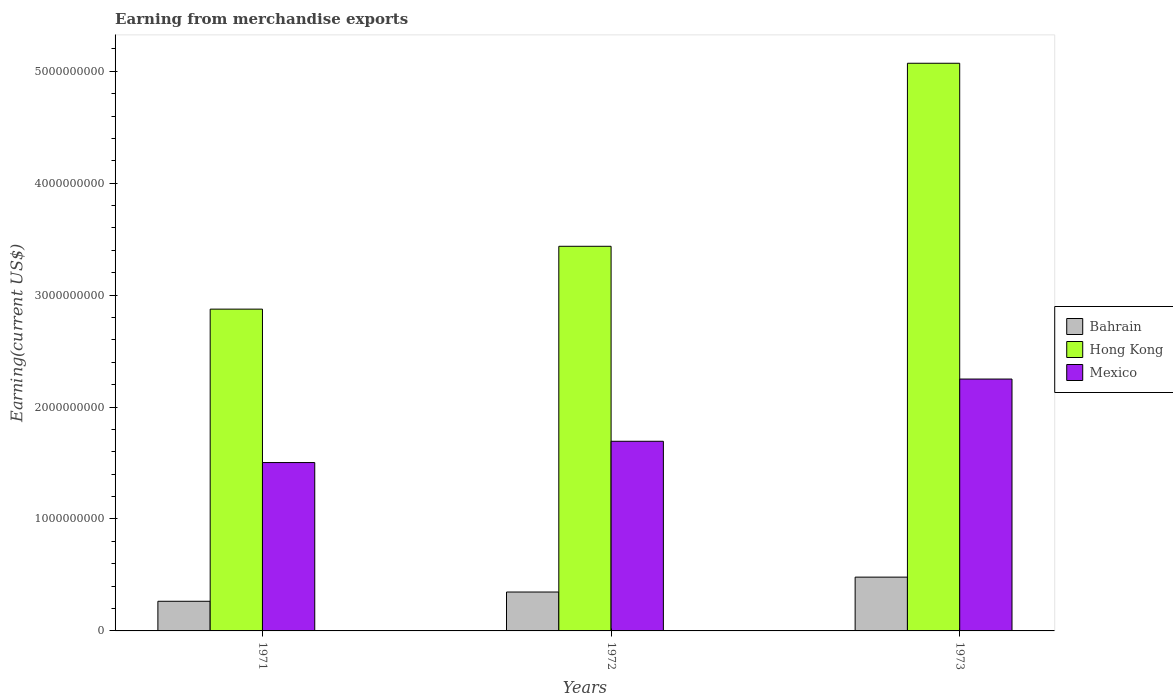How many different coloured bars are there?
Offer a terse response. 3. Are the number of bars per tick equal to the number of legend labels?
Offer a very short reply. Yes. Are the number of bars on each tick of the X-axis equal?
Offer a very short reply. Yes. In how many cases, is the number of bars for a given year not equal to the number of legend labels?
Your answer should be very brief. 0. What is the amount earned from merchandise exports in Bahrain in 1971?
Provide a succinct answer. 2.65e+08. Across all years, what is the maximum amount earned from merchandise exports in Hong Kong?
Your response must be concise. 5.07e+09. Across all years, what is the minimum amount earned from merchandise exports in Hong Kong?
Provide a succinct answer. 2.87e+09. In which year was the amount earned from merchandise exports in Bahrain minimum?
Make the answer very short. 1971. What is the total amount earned from merchandise exports in Mexico in the graph?
Offer a terse response. 5.45e+09. What is the difference between the amount earned from merchandise exports in Hong Kong in 1971 and that in 1973?
Keep it short and to the point. -2.20e+09. What is the difference between the amount earned from merchandise exports in Hong Kong in 1973 and the amount earned from merchandise exports in Mexico in 1972?
Make the answer very short. 3.38e+09. What is the average amount earned from merchandise exports in Bahrain per year?
Offer a very short reply. 3.64e+08. In the year 1972, what is the difference between the amount earned from merchandise exports in Mexico and amount earned from merchandise exports in Bahrain?
Ensure brevity in your answer.  1.35e+09. In how many years, is the amount earned from merchandise exports in Mexico greater than 4400000000 US$?
Your response must be concise. 0. What is the ratio of the amount earned from merchandise exports in Bahrain in 1972 to that in 1973?
Offer a very short reply. 0.72. Is the difference between the amount earned from merchandise exports in Mexico in 1971 and 1973 greater than the difference between the amount earned from merchandise exports in Bahrain in 1971 and 1973?
Ensure brevity in your answer.  No. What is the difference between the highest and the second highest amount earned from merchandise exports in Bahrain?
Give a very brief answer. 1.33e+08. What is the difference between the highest and the lowest amount earned from merchandise exports in Hong Kong?
Your answer should be compact. 2.20e+09. Is the sum of the amount earned from merchandise exports in Hong Kong in 1971 and 1972 greater than the maximum amount earned from merchandise exports in Mexico across all years?
Your answer should be compact. Yes. What does the 2nd bar from the left in 1971 represents?
Your answer should be compact. Hong Kong. What does the 3rd bar from the right in 1972 represents?
Ensure brevity in your answer.  Bahrain. Are all the bars in the graph horizontal?
Offer a terse response. No. How many years are there in the graph?
Your answer should be compact. 3. What is the difference between two consecutive major ticks on the Y-axis?
Your response must be concise. 1.00e+09. How are the legend labels stacked?
Give a very brief answer. Vertical. What is the title of the graph?
Provide a succinct answer. Earning from merchandise exports. Does "Cabo Verde" appear as one of the legend labels in the graph?
Make the answer very short. No. What is the label or title of the X-axis?
Ensure brevity in your answer.  Years. What is the label or title of the Y-axis?
Offer a very short reply. Earning(current US$). What is the Earning(current US$) in Bahrain in 1971?
Offer a very short reply. 2.65e+08. What is the Earning(current US$) of Hong Kong in 1971?
Offer a terse response. 2.87e+09. What is the Earning(current US$) in Mexico in 1971?
Your answer should be very brief. 1.50e+09. What is the Earning(current US$) of Bahrain in 1972?
Offer a very short reply. 3.47e+08. What is the Earning(current US$) in Hong Kong in 1972?
Give a very brief answer. 3.44e+09. What is the Earning(current US$) in Mexico in 1972?
Keep it short and to the point. 1.69e+09. What is the Earning(current US$) of Bahrain in 1973?
Keep it short and to the point. 4.81e+08. What is the Earning(current US$) of Hong Kong in 1973?
Keep it short and to the point. 5.07e+09. What is the Earning(current US$) of Mexico in 1973?
Offer a very short reply. 2.25e+09. Across all years, what is the maximum Earning(current US$) in Bahrain?
Provide a succinct answer. 4.81e+08. Across all years, what is the maximum Earning(current US$) in Hong Kong?
Keep it short and to the point. 5.07e+09. Across all years, what is the maximum Earning(current US$) of Mexico?
Your answer should be compact. 2.25e+09. Across all years, what is the minimum Earning(current US$) of Bahrain?
Make the answer very short. 2.65e+08. Across all years, what is the minimum Earning(current US$) in Hong Kong?
Offer a very short reply. 2.87e+09. Across all years, what is the minimum Earning(current US$) of Mexico?
Offer a very short reply. 1.50e+09. What is the total Earning(current US$) in Bahrain in the graph?
Your answer should be compact. 1.09e+09. What is the total Earning(current US$) in Hong Kong in the graph?
Your answer should be compact. 1.14e+1. What is the total Earning(current US$) in Mexico in the graph?
Your answer should be compact. 5.45e+09. What is the difference between the Earning(current US$) of Bahrain in 1971 and that in 1972?
Your answer should be compact. -8.25e+07. What is the difference between the Earning(current US$) in Hong Kong in 1971 and that in 1972?
Provide a short and direct response. -5.62e+08. What is the difference between the Earning(current US$) of Mexico in 1971 and that in 1972?
Provide a short and direct response. -1.90e+08. What is the difference between the Earning(current US$) of Bahrain in 1971 and that in 1973?
Your answer should be very brief. -2.16e+08. What is the difference between the Earning(current US$) of Hong Kong in 1971 and that in 1973?
Make the answer very short. -2.20e+09. What is the difference between the Earning(current US$) in Mexico in 1971 and that in 1973?
Your answer should be compact. -7.46e+08. What is the difference between the Earning(current US$) in Bahrain in 1972 and that in 1973?
Provide a succinct answer. -1.33e+08. What is the difference between the Earning(current US$) in Hong Kong in 1972 and that in 1973?
Your answer should be compact. -1.64e+09. What is the difference between the Earning(current US$) in Mexico in 1972 and that in 1973?
Ensure brevity in your answer.  -5.56e+08. What is the difference between the Earning(current US$) of Bahrain in 1971 and the Earning(current US$) of Hong Kong in 1972?
Your response must be concise. -3.17e+09. What is the difference between the Earning(current US$) of Bahrain in 1971 and the Earning(current US$) of Mexico in 1972?
Your answer should be very brief. -1.43e+09. What is the difference between the Earning(current US$) in Hong Kong in 1971 and the Earning(current US$) in Mexico in 1972?
Make the answer very short. 1.18e+09. What is the difference between the Earning(current US$) of Bahrain in 1971 and the Earning(current US$) of Hong Kong in 1973?
Offer a very short reply. -4.81e+09. What is the difference between the Earning(current US$) of Bahrain in 1971 and the Earning(current US$) of Mexico in 1973?
Give a very brief answer. -1.99e+09. What is the difference between the Earning(current US$) in Hong Kong in 1971 and the Earning(current US$) in Mexico in 1973?
Provide a succinct answer. 6.25e+08. What is the difference between the Earning(current US$) in Bahrain in 1972 and the Earning(current US$) in Hong Kong in 1973?
Provide a short and direct response. -4.72e+09. What is the difference between the Earning(current US$) in Bahrain in 1972 and the Earning(current US$) in Mexico in 1973?
Keep it short and to the point. -1.90e+09. What is the difference between the Earning(current US$) of Hong Kong in 1972 and the Earning(current US$) of Mexico in 1973?
Your response must be concise. 1.19e+09. What is the average Earning(current US$) in Bahrain per year?
Provide a succinct answer. 3.64e+08. What is the average Earning(current US$) of Hong Kong per year?
Your response must be concise. 3.79e+09. What is the average Earning(current US$) of Mexico per year?
Make the answer very short. 1.82e+09. In the year 1971, what is the difference between the Earning(current US$) in Bahrain and Earning(current US$) in Hong Kong?
Ensure brevity in your answer.  -2.61e+09. In the year 1971, what is the difference between the Earning(current US$) in Bahrain and Earning(current US$) in Mexico?
Your answer should be very brief. -1.24e+09. In the year 1971, what is the difference between the Earning(current US$) of Hong Kong and Earning(current US$) of Mexico?
Offer a terse response. 1.37e+09. In the year 1972, what is the difference between the Earning(current US$) in Bahrain and Earning(current US$) in Hong Kong?
Your answer should be very brief. -3.09e+09. In the year 1972, what is the difference between the Earning(current US$) in Bahrain and Earning(current US$) in Mexico?
Provide a succinct answer. -1.35e+09. In the year 1972, what is the difference between the Earning(current US$) of Hong Kong and Earning(current US$) of Mexico?
Ensure brevity in your answer.  1.74e+09. In the year 1973, what is the difference between the Earning(current US$) in Bahrain and Earning(current US$) in Hong Kong?
Provide a short and direct response. -4.59e+09. In the year 1973, what is the difference between the Earning(current US$) in Bahrain and Earning(current US$) in Mexico?
Provide a short and direct response. -1.77e+09. In the year 1973, what is the difference between the Earning(current US$) of Hong Kong and Earning(current US$) of Mexico?
Provide a succinct answer. 2.82e+09. What is the ratio of the Earning(current US$) of Bahrain in 1971 to that in 1972?
Provide a short and direct response. 0.76. What is the ratio of the Earning(current US$) in Hong Kong in 1971 to that in 1972?
Provide a short and direct response. 0.84. What is the ratio of the Earning(current US$) of Mexico in 1971 to that in 1972?
Provide a short and direct response. 0.89. What is the ratio of the Earning(current US$) in Bahrain in 1971 to that in 1973?
Provide a short and direct response. 0.55. What is the ratio of the Earning(current US$) in Hong Kong in 1971 to that in 1973?
Give a very brief answer. 0.57. What is the ratio of the Earning(current US$) in Mexico in 1971 to that in 1973?
Ensure brevity in your answer.  0.67. What is the ratio of the Earning(current US$) in Bahrain in 1972 to that in 1973?
Give a very brief answer. 0.72. What is the ratio of the Earning(current US$) of Hong Kong in 1972 to that in 1973?
Ensure brevity in your answer.  0.68. What is the ratio of the Earning(current US$) in Mexico in 1972 to that in 1973?
Keep it short and to the point. 0.75. What is the difference between the highest and the second highest Earning(current US$) of Bahrain?
Your answer should be very brief. 1.33e+08. What is the difference between the highest and the second highest Earning(current US$) of Hong Kong?
Your response must be concise. 1.64e+09. What is the difference between the highest and the second highest Earning(current US$) in Mexico?
Ensure brevity in your answer.  5.56e+08. What is the difference between the highest and the lowest Earning(current US$) in Bahrain?
Ensure brevity in your answer.  2.16e+08. What is the difference between the highest and the lowest Earning(current US$) of Hong Kong?
Offer a terse response. 2.20e+09. What is the difference between the highest and the lowest Earning(current US$) in Mexico?
Your response must be concise. 7.46e+08. 